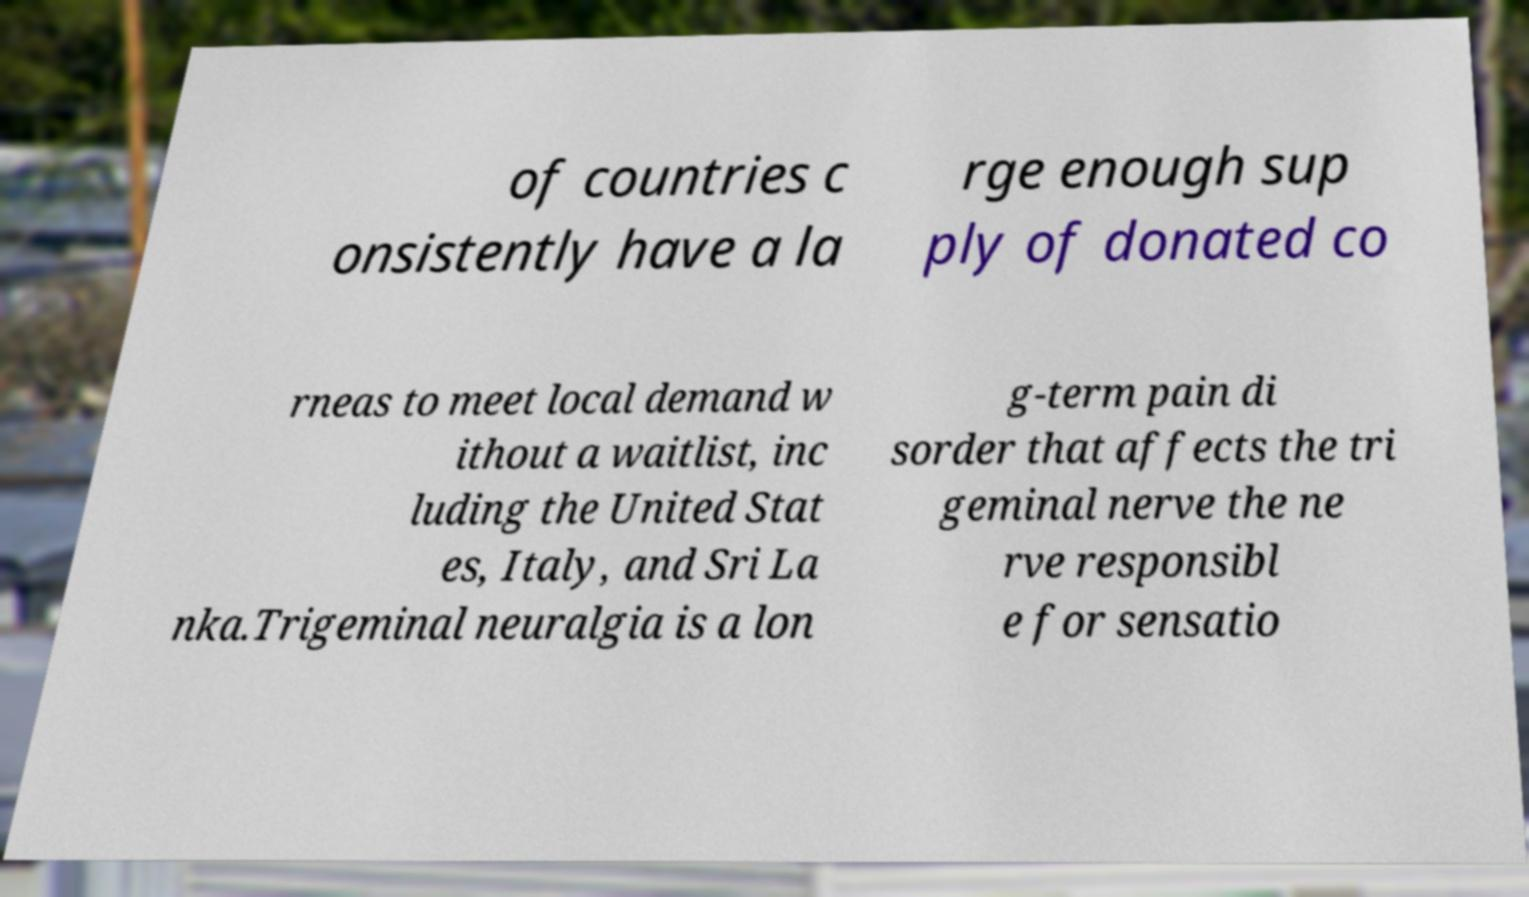Could you extract and type out the text from this image? of countries c onsistently have a la rge enough sup ply of donated co rneas to meet local demand w ithout a waitlist, inc luding the United Stat es, Italy, and Sri La nka.Trigeminal neuralgia is a lon g-term pain di sorder that affects the tri geminal nerve the ne rve responsibl e for sensatio 